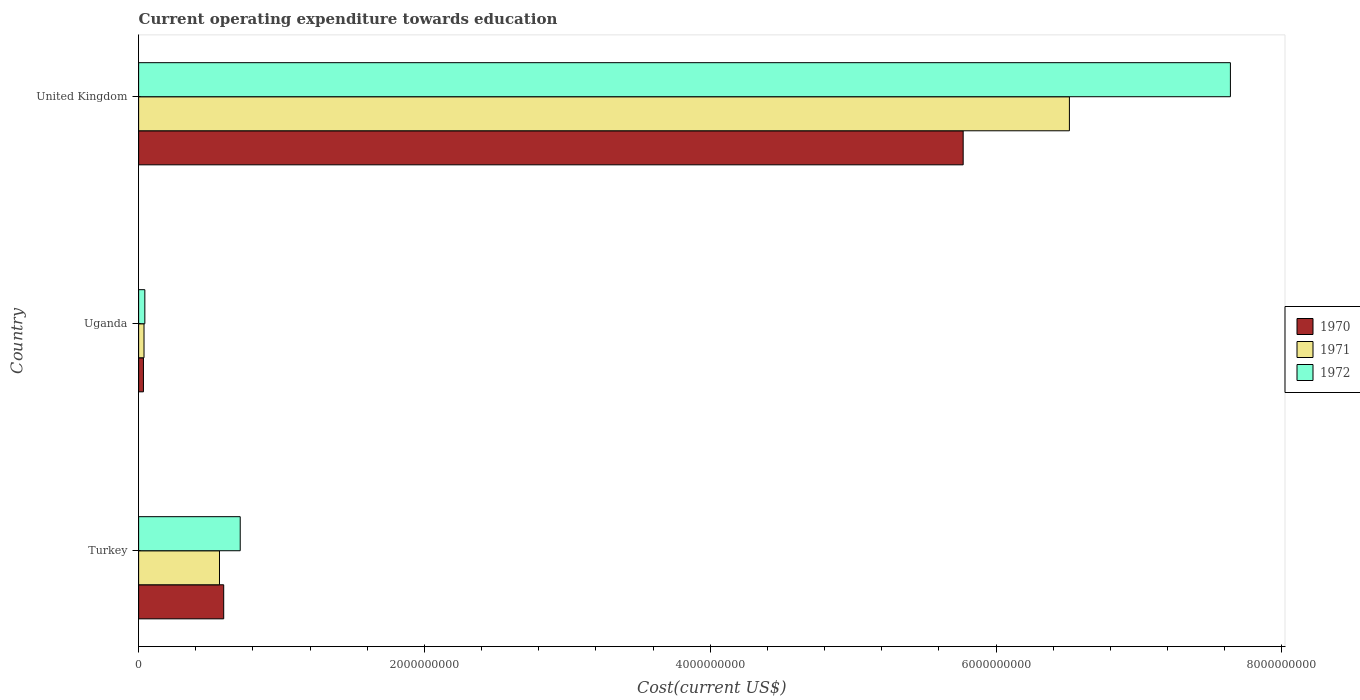Are the number of bars per tick equal to the number of legend labels?
Offer a terse response. Yes. How many bars are there on the 1st tick from the bottom?
Provide a succinct answer. 3. What is the label of the 1st group of bars from the top?
Provide a short and direct response. United Kingdom. In how many cases, is the number of bars for a given country not equal to the number of legend labels?
Your response must be concise. 0. What is the expenditure towards education in 1971 in Uganda?
Offer a terse response. 3.77e+07. Across all countries, what is the maximum expenditure towards education in 1970?
Provide a succinct answer. 5.77e+09. Across all countries, what is the minimum expenditure towards education in 1972?
Offer a terse response. 4.35e+07. In which country was the expenditure towards education in 1970 maximum?
Offer a terse response. United Kingdom. In which country was the expenditure towards education in 1972 minimum?
Keep it short and to the point. Uganda. What is the total expenditure towards education in 1972 in the graph?
Give a very brief answer. 8.39e+09. What is the difference between the expenditure towards education in 1972 in Turkey and that in United Kingdom?
Provide a succinct answer. -6.93e+09. What is the difference between the expenditure towards education in 1972 in Uganda and the expenditure towards education in 1971 in Turkey?
Your answer should be compact. -5.22e+08. What is the average expenditure towards education in 1971 per country?
Provide a succinct answer. 2.37e+09. What is the difference between the expenditure towards education in 1970 and expenditure towards education in 1971 in United Kingdom?
Provide a succinct answer. -7.43e+08. What is the ratio of the expenditure towards education in 1971 in Uganda to that in United Kingdom?
Offer a very short reply. 0.01. Is the expenditure towards education in 1970 in Turkey less than that in United Kingdom?
Give a very brief answer. Yes. Is the difference between the expenditure towards education in 1970 in Turkey and United Kingdom greater than the difference between the expenditure towards education in 1971 in Turkey and United Kingdom?
Provide a short and direct response. Yes. What is the difference between the highest and the second highest expenditure towards education in 1972?
Offer a very short reply. 6.93e+09. What is the difference between the highest and the lowest expenditure towards education in 1972?
Provide a short and direct response. 7.60e+09. Is the sum of the expenditure towards education in 1970 in Turkey and Uganda greater than the maximum expenditure towards education in 1971 across all countries?
Your answer should be very brief. No. What does the 2nd bar from the top in Turkey represents?
Keep it short and to the point. 1971. How many bars are there?
Provide a short and direct response. 9. What is the difference between two consecutive major ticks on the X-axis?
Give a very brief answer. 2.00e+09. Are the values on the major ticks of X-axis written in scientific E-notation?
Give a very brief answer. No. Does the graph contain any zero values?
Give a very brief answer. No. Does the graph contain grids?
Make the answer very short. No. How many legend labels are there?
Give a very brief answer. 3. What is the title of the graph?
Your answer should be compact. Current operating expenditure towards education. What is the label or title of the X-axis?
Offer a terse response. Cost(current US$). What is the label or title of the Y-axis?
Ensure brevity in your answer.  Country. What is the Cost(current US$) of 1970 in Turkey?
Your answer should be compact. 5.95e+08. What is the Cost(current US$) in 1971 in Turkey?
Offer a very short reply. 5.66e+08. What is the Cost(current US$) of 1972 in Turkey?
Offer a very short reply. 7.11e+08. What is the Cost(current US$) in 1970 in Uganda?
Provide a succinct answer. 3.36e+07. What is the Cost(current US$) in 1971 in Uganda?
Your answer should be compact. 3.77e+07. What is the Cost(current US$) in 1972 in Uganda?
Your answer should be compact. 4.35e+07. What is the Cost(current US$) of 1970 in United Kingdom?
Provide a succinct answer. 5.77e+09. What is the Cost(current US$) in 1971 in United Kingdom?
Your response must be concise. 6.51e+09. What is the Cost(current US$) in 1972 in United Kingdom?
Make the answer very short. 7.64e+09. Across all countries, what is the maximum Cost(current US$) in 1970?
Provide a short and direct response. 5.77e+09. Across all countries, what is the maximum Cost(current US$) in 1971?
Offer a terse response. 6.51e+09. Across all countries, what is the maximum Cost(current US$) in 1972?
Provide a short and direct response. 7.64e+09. Across all countries, what is the minimum Cost(current US$) in 1970?
Provide a short and direct response. 3.36e+07. Across all countries, what is the minimum Cost(current US$) of 1971?
Provide a succinct answer. 3.77e+07. Across all countries, what is the minimum Cost(current US$) of 1972?
Ensure brevity in your answer.  4.35e+07. What is the total Cost(current US$) of 1970 in the graph?
Offer a very short reply. 6.40e+09. What is the total Cost(current US$) of 1971 in the graph?
Your answer should be compact. 7.12e+09. What is the total Cost(current US$) of 1972 in the graph?
Keep it short and to the point. 8.39e+09. What is the difference between the Cost(current US$) in 1970 in Turkey and that in Uganda?
Ensure brevity in your answer.  5.62e+08. What is the difference between the Cost(current US$) in 1971 in Turkey and that in Uganda?
Your answer should be very brief. 5.28e+08. What is the difference between the Cost(current US$) of 1972 in Turkey and that in Uganda?
Offer a very short reply. 6.67e+08. What is the difference between the Cost(current US$) of 1970 in Turkey and that in United Kingdom?
Ensure brevity in your answer.  -5.17e+09. What is the difference between the Cost(current US$) of 1971 in Turkey and that in United Kingdom?
Your response must be concise. -5.95e+09. What is the difference between the Cost(current US$) of 1972 in Turkey and that in United Kingdom?
Make the answer very short. -6.93e+09. What is the difference between the Cost(current US$) in 1970 in Uganda and that in United Kingdom?
Make the answer very short. -5.74e+09. What is the difference between the Cost(current US$) of 1971 in Uganda and that in United Kingdom?
Keep it short and to the point. -6.48e+09. What is the difference between the Cost(current US$) in 1972 in Uganda and that in United Kingdom?
Give a very brief answer. -7.60e+09. What is the difference between the Cost(current US$) of 1970 in Turkey and the Cost(current US$) of 1971 in Uganda?
Provide a succinct answer. 5.58e+08. What is the difference between the Cost(current US$) of 1970 in Turkey and the Cost(current US$) of 1972 in Uganda?
Your answer should be very brief. 5.52e+08. What is the difference between the Cost(current US$) in 1971 in Turkey and the Cost(current US$) in 1972 in Uganda?
Keep it short and to the point. 5.22e+08. What is the difference between the Cost(current US$) in 1970 in Turkey and the Cost(current US$) in 1971 in United Kingdom?
Your answer should be very brief. -5.92e+09. What is the difference between the Cost(current US$) of 1970 in Turkey and the Cost(current US$) of 1972 in United Kingdom?
Ensure brevity in your answer.  -7.04e+09. What is the difference between the Cost(current US$) of 1971 in Turkey and the Cost(current US$) of 1972 in United Kingdom?
Your response must be concise. -7.07e+09. What is the difference between the Cost(current US$) in 1970 in Uganda and the Cost(current US$) in 1971 in United Kingdom?
Provide a succinct answer. -6.48e+09. What is the difference between the Cost(current US$) in 1970 in Uganda and the Cost(current US$) in 1972 in United Kingdom?
Your response must be concise. -7.61e+09. What is the difference between the Cost(current US$) in 1971 in Uganda and the Cost(current US$) in 1972 in United Kingdom?
Provide a succinct answer. -7.60e+09. What is the average Cost(current US$) of 1970 per country?
Your answer should be compact. 2.13e+09. What is the average Cost(current US$) in 1971 per country?
Your response must be concise. 2.37e+09. What is the average Cost(current US$) in 1972 per country?
Ensure brevity in your answer.  2.80e+09. What is the difference between the Cost(current US$) in 1970 and Cost(current US$) in 1971 in Turkey?
Give a very brief answer. 2.95e+07. What is the difference between the Cost(current US$) in 1970 and Cost(current US$) in 1972 in Turkey?
Your response must be concise. -1.16e+08. What is the difference between the Cost(current US$) in 1971 and Cost(current US$) in 1972 in Turkey?
Ensure brevity in your answer.  -1.45e+08. What is the difference between the Cost(current US$) in 1970 and Cost(current US$) in 1971 in Uganda?
Keep it short and to the point. -4.06e+06. What is the difference between the Cost(current US$) of 1970 and Cost(current US$) of 1972 in Uganda?
Provide a succinct answer. -9.89e+06. What is the difference between the Cost(current US$) of 1971 and Cost(current US$) of 1972 in Uganda?
Your answer should be compact. -5.83e+06. What is the difference between the Cost(current US$) of 1970 and Cost(current US$) of 1971 in United Kingdom?
Provide a succinct answer. -7.43e+08. What is the difference between the Cost(current US$) in 1970 and Cost(current US$) in 1972 in United Kingdom?
Offer a very short reply. -1.87e+09. What is the difference between the Cost(current US$) in 1971 and Cost(current US$) in 1972 in United Kingdom?
Ensure brevity in your answer.  -1.13e+09. What is the ratio of the Cost(current US$) in 1970 in Turkey to that in Uganda?
Your answer should be compact. 17.71. What is the ratio of the Cost(current US$) in 1971 in Turkey to that in Uganda?
Provide a short and direct response. 15.02. What is the ratio of the Cost(current US$) in 1972 in Turkey to that in Uganda?
Give a very brief answer. 16.34. What is the ratio of the Cost(current US$) of 1970 in Turkey to that in United Kingdom?
Offer a very short reply. 0.1. What is the ratio of the Cost(current US$) of 1971 in Turkey to that in United Kingdom?
Your answer should be compact. 0.09. What is the ratio of the Cost(current US$) in 1972 in Turkey to that in United Kingdom?
Provide a succinct answer. 0.09. What is the ratio of the Cost(current US$) in 1970 in Uganda to that in United Kingdom?
Give a very brief answer. 0.01. What is the ratio of the Cost(current US$) of 1971 in Uganda to that in United Kingdom?
Provide a short and direct response. 0.01. What is the ratio of the Cost(current US$) of 1972 in Uganda to that in United Kingdom?
Provide a succinct answer. 0.01. What is the difference between the highest and the second highest Cost(current US$) of 1970?
Your answer should be very brief. 5.17e+09. What is the difference between the highest and the second highest Cost(current US$) of 1971?
Offer a terse response. 5.95e+09. What is the difference between the highest and the second highest Cost(current US$) in 1972?
Offer a terse response. 6.93e+09. What is the difference between the highest and the lowest Cost(current US$) of 1970?
Provide a succinct answer. 5.74e+09. What is the difference between the highest and the lowest Cost(current US$) in 1971?
Offer a very short reply. 6.48e+09. What is the difference between the highest and the lowest Cost(current US$) in 1972?
Provide a short and direct response. 7.60e+09. 